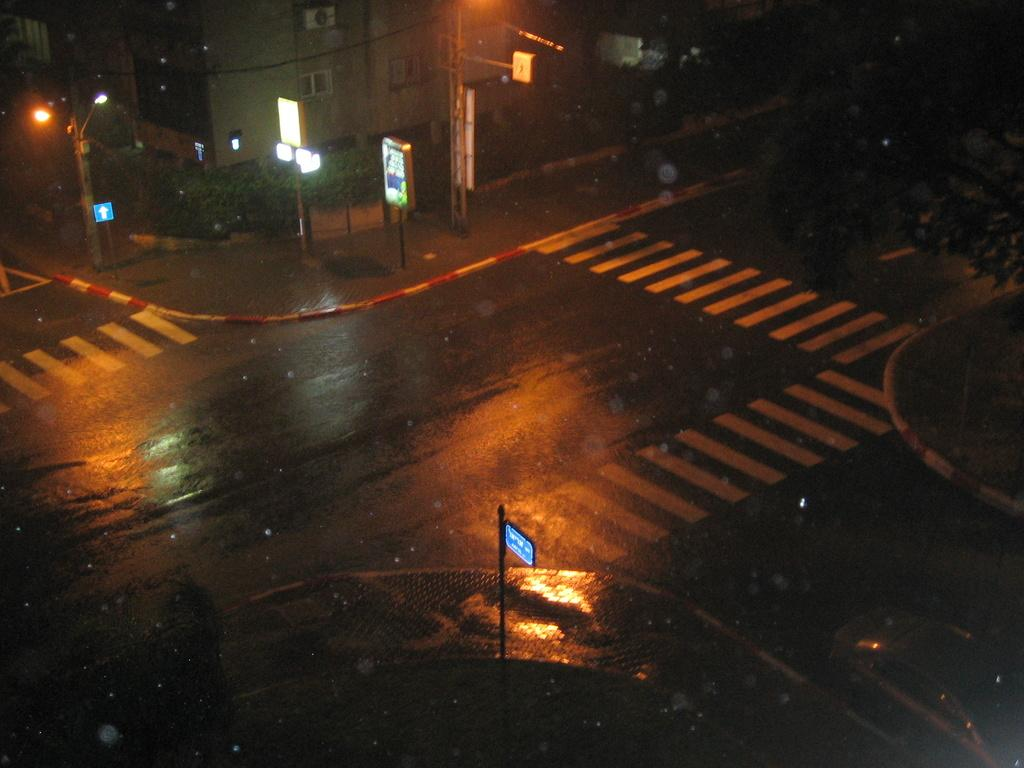What is the lighting condition in the image? The image is taken in the dark. What can be seen on the ground in the image? There is a road in the image. What is present in the foreground of the image? There is a board in the image. What can be seen in the distance in the image? There is a building in the background of the image. What type of engine can be seen on the board in the image? There is no engine present on the board in the image. How many pears are visible on the road in the image? There are no pears visible on the road in the image. 